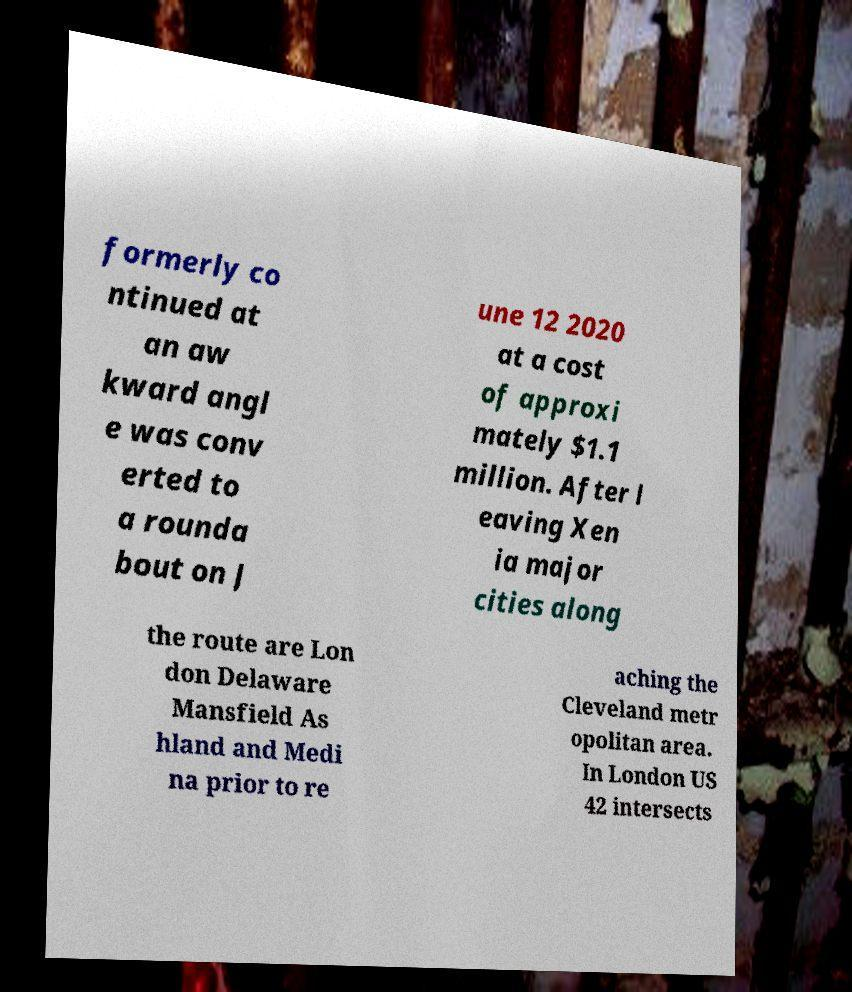For documentation purposes, I need the text within this image transcribed. Could you provide that? formerly co ntinued at an aw kward angl e was conv erted to a rounda bout on J une 12 2020 at a cost of approxi mately $1.1 million. After l eaving Xen ia major cities along the route are Lon don Delaware Mansfield As hland and Medi na prior to re aching the Cleveland metr opolitan area. In London US 42 intersects 